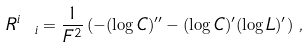<formula> <loc_0><loc_0><loc_500><loc_500>R ^ { i } _ { \ i } = \frac { 1 } { F ^ { 2 } } \left ( - ( \log C ) ^ { \prime \prime } - ( \log C ) ^ { \prime } ( \log L ) ^ { \prime } \right ) \, ,</formula> 